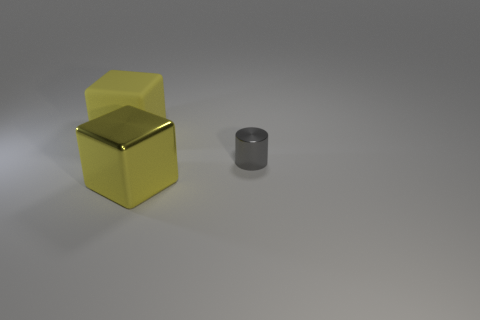Is the number of small objects greater than the number of big things?
Ensure brevity in your answer.  No. Is there any other thing that is the same color as the cylinder?
Your response must be concise. No. The block that is made of the same material as the cylinder is what size?
Make the answer very short. Large. What material is the tiny cylinder?
Provide a succinct answer. Metal. What number of other shiny things have the same size as the gray metallic object?
Offer a terse response. 0. What shape is the big metallic object that is the same color as the large matte block?
Keep it short and to the point. Cube. Is there a red thing that has the same shape as the small gray metal thing?
Provide a succinct answer. No. What is the color of the rubber object that is the same size as the yellow shiny thing?
Provide a succinct answer. Yellow. There is a cube in front of the thing behind the small gray metal object; what is its color?
Your answer should be very brief. Yellow. There is a big thing that is behind the large metal cube; is it the same color as the large metal thing?
Offer a very short reply. Yes. 